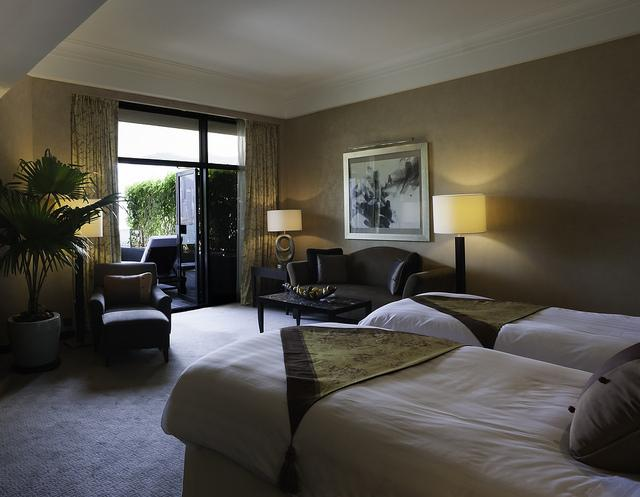What is the tray on the coffee table filled with most likely as decoration? fruit 